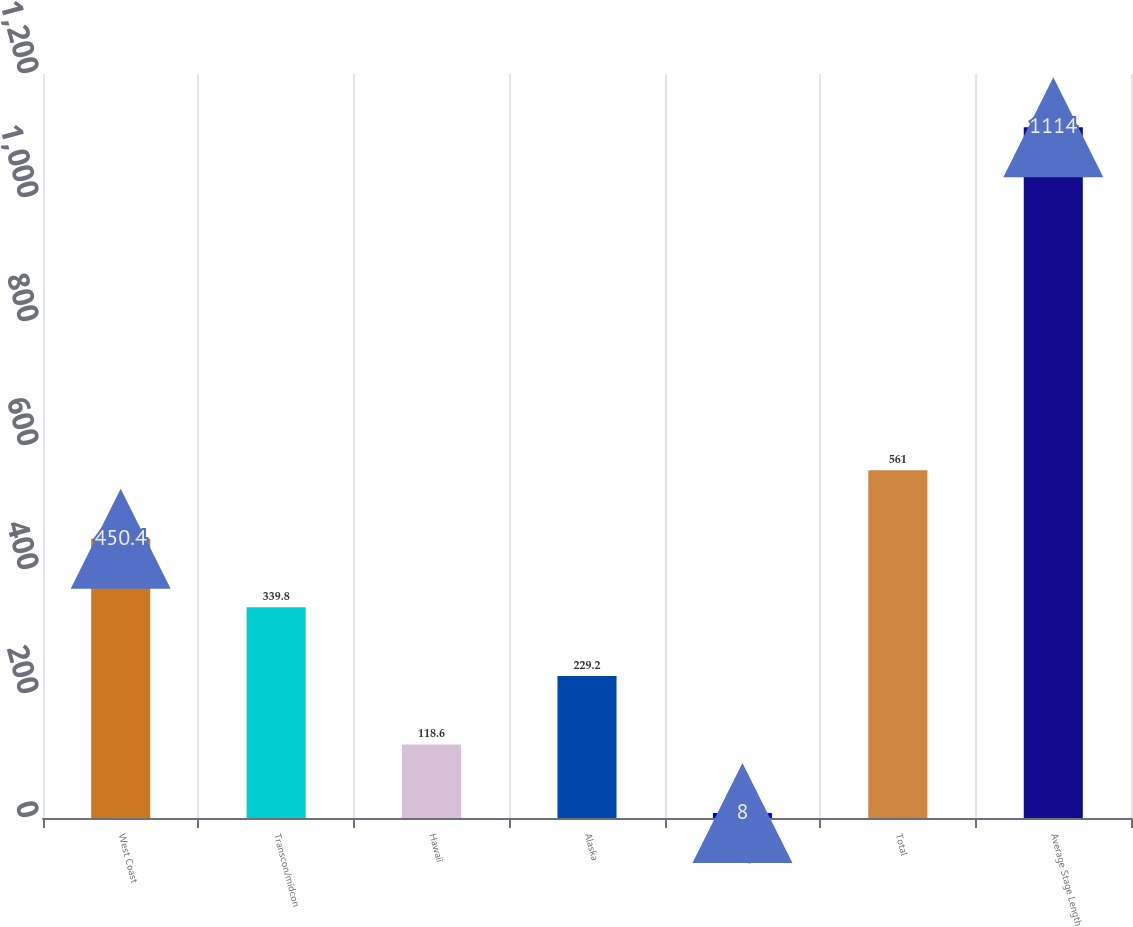<chart> <loc_0><loc_0><loc_500><loc_500><bar_chart><fcel>West Coast<fcel>Transcon/midcon<fcel>Hawaii<fcel>Alaska<fcel>Mexico<fcel>Total<fcel>Average Stage Length<nl><fcel>450.4<fcel>339.8<fcel>118.6<fcel>229.2<fcel>8<fcel>561<fcel>1114<nl></chart> 